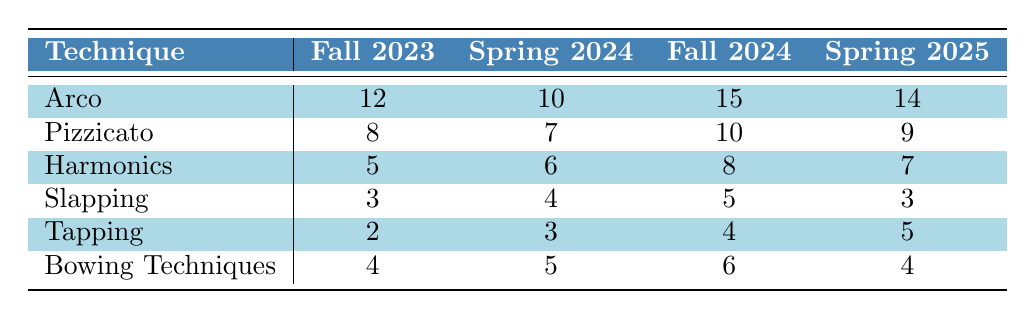What is the highest count of Pizzicato techniques taught, and in which semester did it occur? The highest count of Pizzicato techniques is 10, which occurs in the Fall 2024 semester.
Answer: 10, Fall 2024 How many techniques were taught in total during Spring 2024? To find the total, add the counts of each technique for Spring 2024: 10 (Arco) + 7 (Pizzicato) + 6 (Harmonics) + 4 (Slapping) + 3 (Tapping) + 5 (Bowing Techniques) = 35.
Answer: 35 Did the count of Harmonics techniques taught increase from Fall 2023 to Fall 2024? Harmonics techniques for Fall 2023 is 5 and for Fall 2024 is 8. Since 8 is greater than 5, the count did increase.
Answer: Yes Which semester had the least number of Slapping techniques taught? Looking at the counts of Slapping techniques: Fall 2023 (3), Spring 2024 (4), Fall 2024 (5), and Spring 2025 (3). The least counts are 3 in Fall 2023 and Spring 2025.
Answer: Fall 2023 and Spring 2025 What is the average count of Tapping techniques taught across all semesters? To calculate the average Tapping counts, first sum them: 2 (Fall 2023) + 3 (Spring 2024) + 4 (Fall 2024) + 5 (Spring 2025) = 14. Then divide by 4 (the number of semesters): 14/4 = 3.5.
Answer: 3.5 In Spring 2025, how many more Arco techniques were taught compared to Tapping techniques? For Spring 2025, Arco techniques count is 14 and Tapping techniques count is 5. The difference is 14 - 5 = 9.
Answer: 9 Which technique showed a consistent increase in count from Fall 2023 to Fall 2024? By comparing the listed counts for each technique across semesters, Harmonics shows an increase: 5 (Fall 2023), 6 (Spring 2024), 8 (Fall 2024) which are all increasing values.
Answer: Harmonics What is the total count of Bowing Techniques taught from Fall 2023 to Spring 2025? The counts are: 4 (Fall 2023) + 5 (Spring 2024) + 6 (Fall 2024) + 4 (Spring 2025) = 19.
Answer: 19 